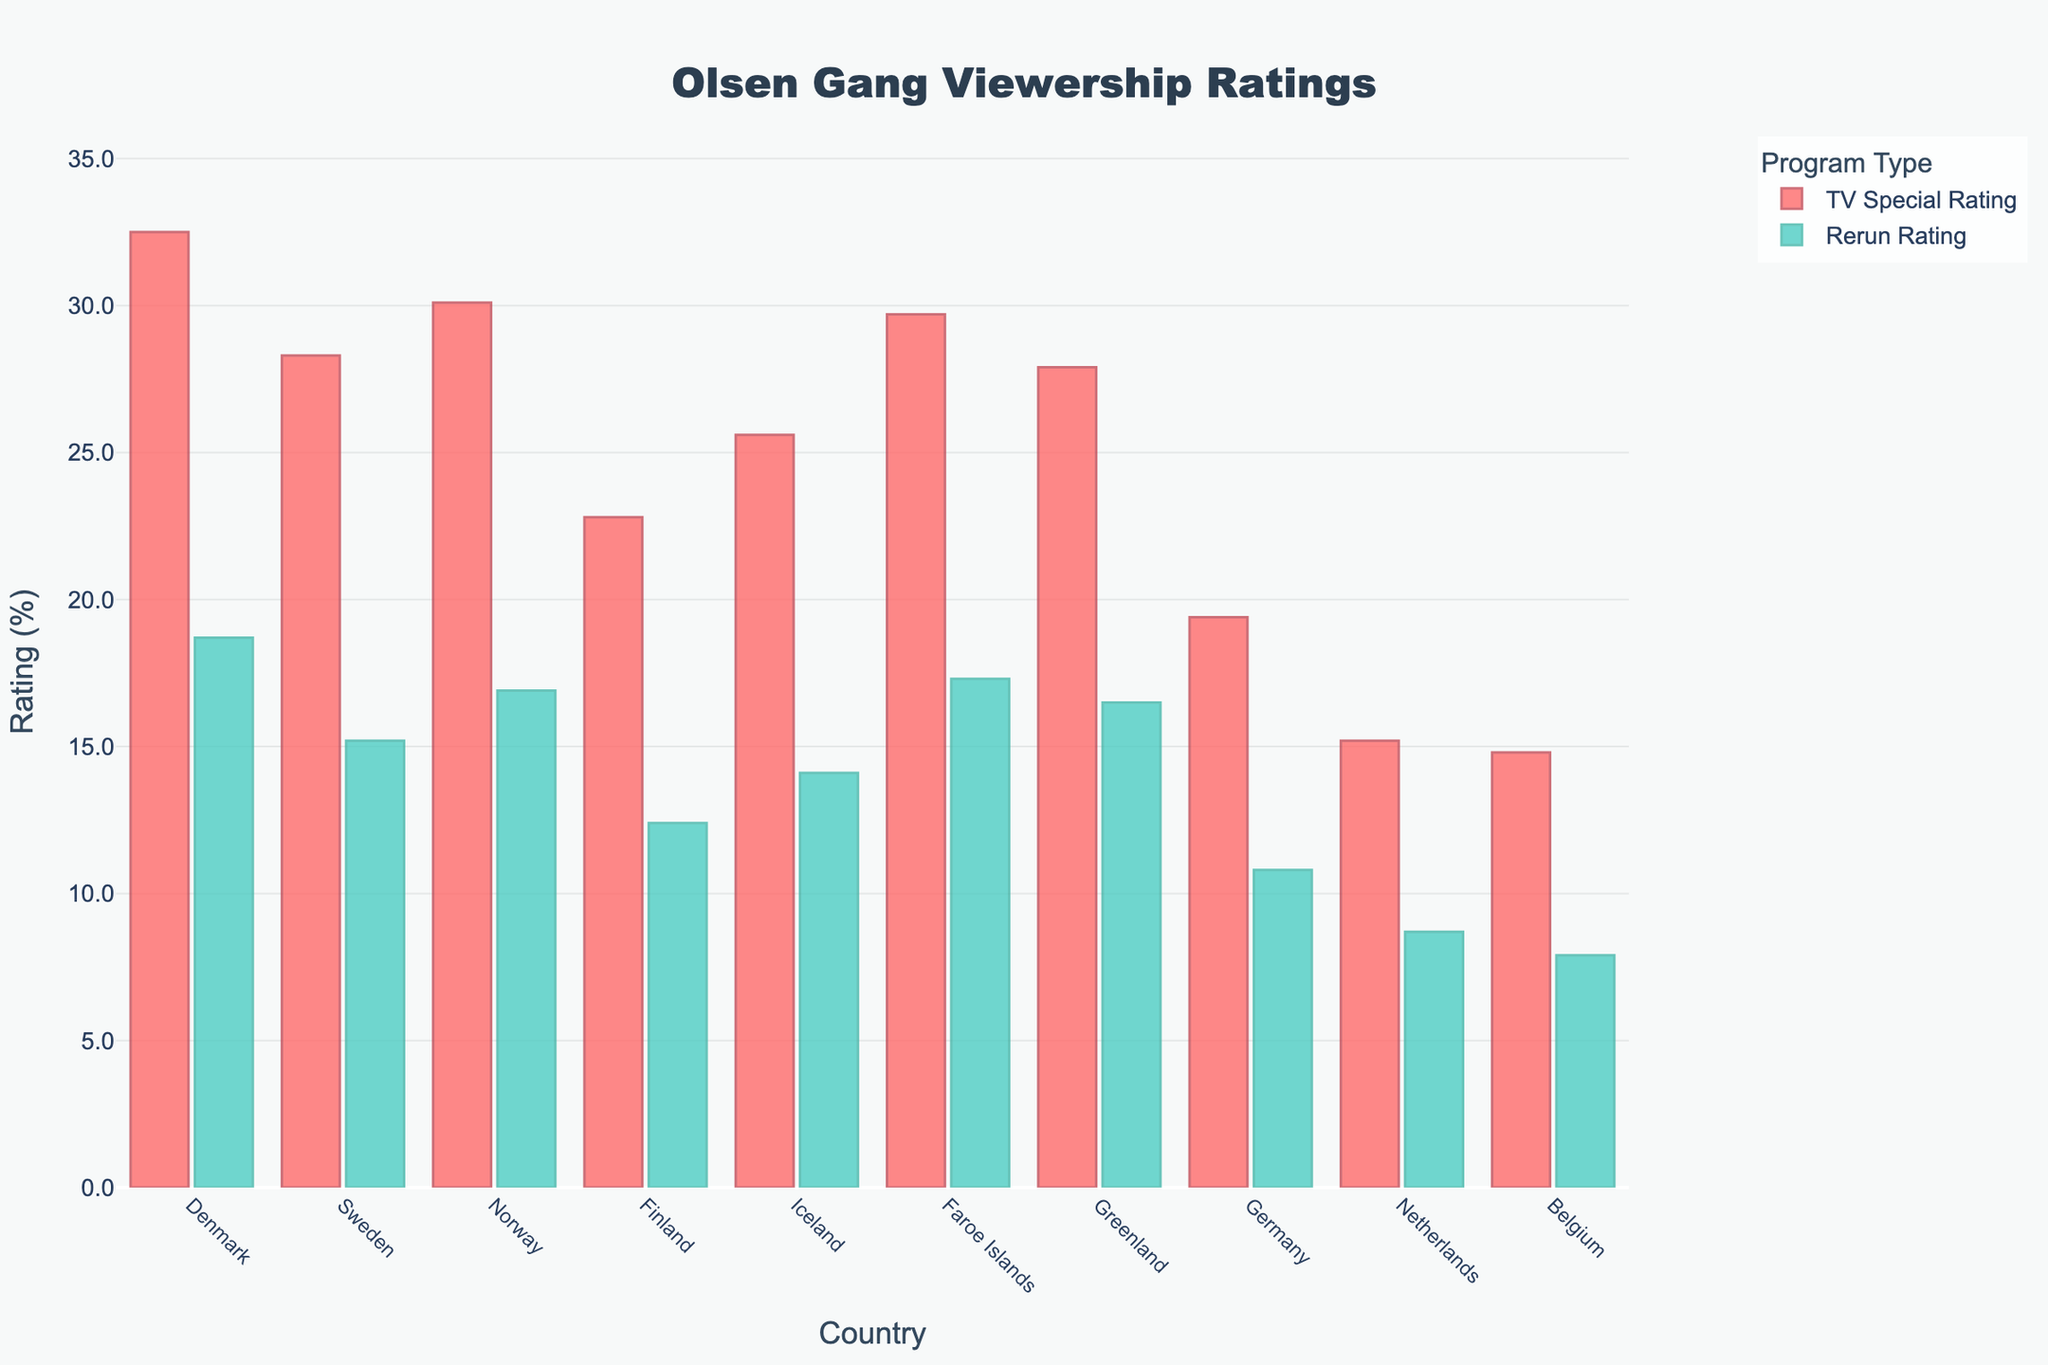Which country has the highest rating for TV specials? By visually inspecting the heights of the bars corresponding to TV Special Ratings, the tallest bar belongs to Denmark.
Answer: Denmark Which country has the lowest rating for reruns? By visually comparing the heights of the bars for Rerun Ratings, the shortest bar belongs to Belgium.
Answer: Belgium What is the difference in TV Special Ratings between Norway and Finland? Norway's TV Special Rating is 30.1 and Finland's is 22.8. Subtract Finland's rating from Norway's: 30.1 - 22.8 = 7.3
Answer: 7.3 Which countries have rerun ratings greater than 15%? By inspecting the heights of the bars in the Rerun Ratings, Denmark, Sweden, Norway, Faroe Islands, Greenland, and Iceland have ratings higher than 15%.
Answer: Denmark, Sweden, Norway, Faroe Islands, Greenland, Iceland How does Denmark's TV Special Rating compare to its Rerun Rating? Denmark's TV Special Rating is 32.5 and its Rerun Rating is 18.7. By comparing these values, the TV Special Rating is higher.
Answer: TV Special Rating is higher What is the average TV Special Rating for Denmark, Sweden, and Norway? Add ratings for Denmark (32.5), Sweden (28.3), and Norway (30.1), then divide by 3: (32.5 + 28.3 + 30.1)/3 = 30.3
Answer: 30.3 Which country has the smallest difference between TV Special and Rerun Ratings? Calculate the differences for each country and compare: Denmark (13.8), Sweden (13.1), Norway (13.2), Finland (10.4), Iceland (11.5), Faroes (12.4), Greenland (11.4), Germany (8.6), Netherlands (6.5), Belgium (6.9). The smallest difference is for Netherlands.
Answer: Netherlands What is the total TV Special Rating for all Scandinavian countries? Scandinavian countries include Denmark, Sweden, Norway, Finland, Iceland. Sum their TV Special Ratings: 32.5 + 28.3 + 30.1 + 22.8 + 25.6 = 139.3
Answer: 139.3 How much higher is the TV Special Rating for Denmark compared to Sweden? Denmark's TV Special Rating is 32.5 and Sweden's is 28.3. Subtract Sweden's rating from Denmark's: 32.5 - 28.3 = 4.2
Answer: 4.2 Which country has a higher rerun rating: Greenland or Faroe Islands? By comparing the heights of the bars for Rerun Ratings, Faroe Islands (17.3) has a higher rating than Greenland (16.5).
Answer: Faroe Islands 